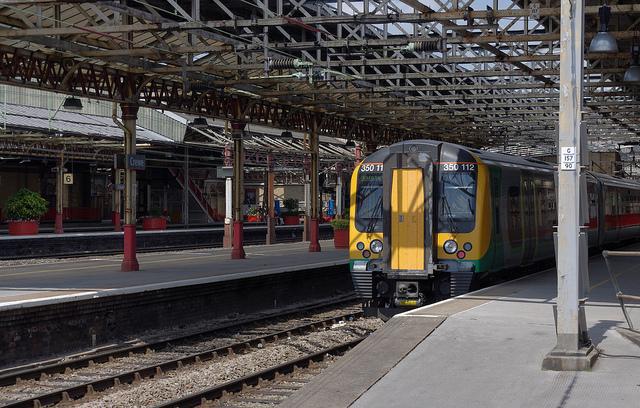What is the train number?
Concise answer only. 350 112. What does the sign say?
Answer briefly. Stop. Is the sky visible?
Give a very brief answer. Yes. What pattern is on the pole?
Answer briefly. None. 